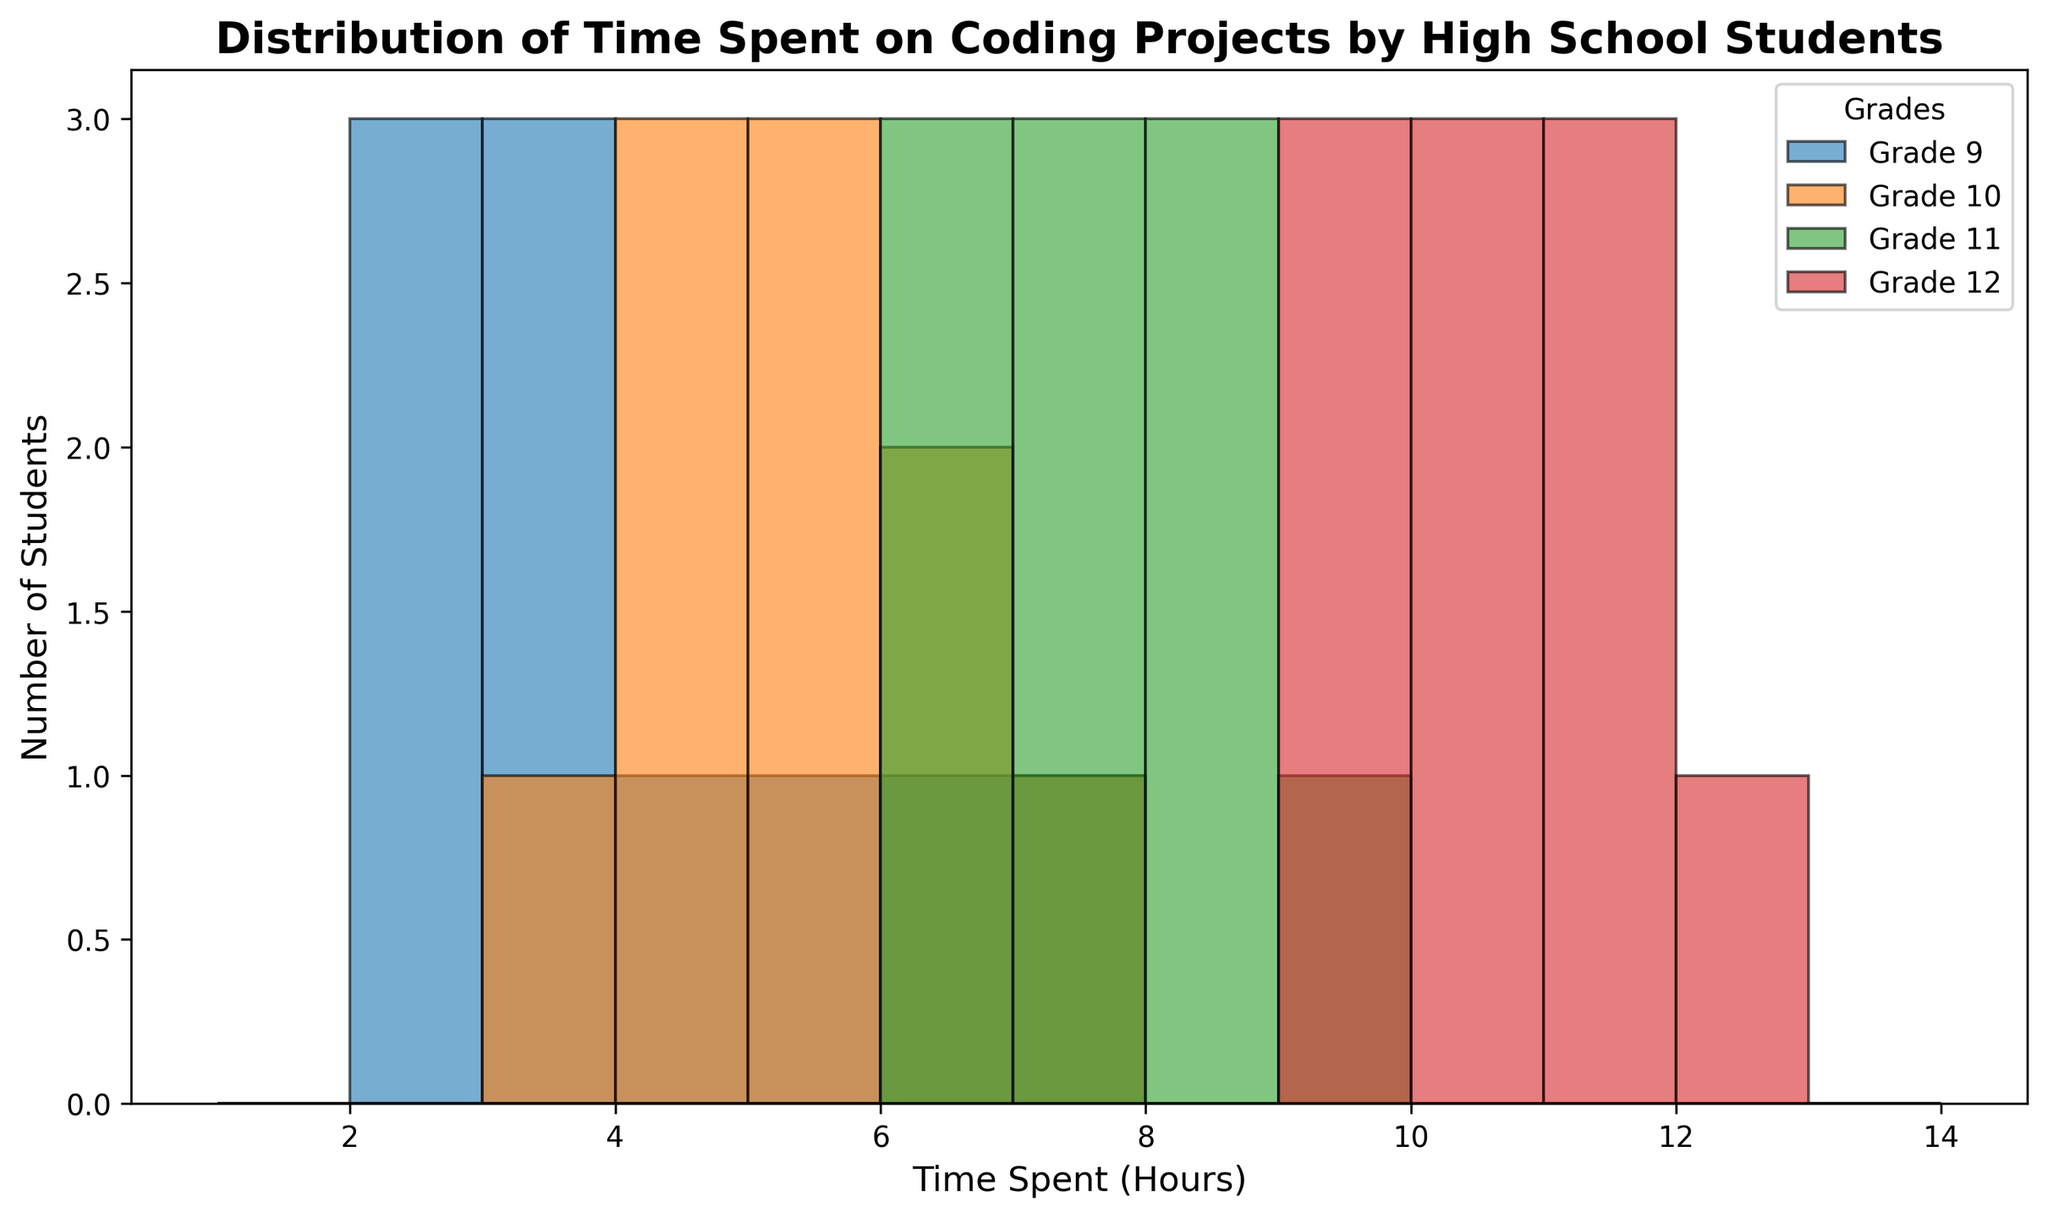What's the range of hours that 9th graders spent on coding projects? The histogram shows the range of hours spent by 9th graders spanning from the minimum to maximum values. Observing the bars representing 9th graders, we see the range starts at 2 and ends at 7 hours.
Answer: 2 to 7 hours Which grade has the highest peak in the histogram? The highest peak is identified by the tallest bar in the histogram. By comparing the height of the bars for each grade, 11th grade has the tallest peak representing 8 hours.
Answer: 11th grade What's the approximate average time spent by 12th graders on coding projects? To get the average, sum all the hours spent by 12th graders and divide by the number of students. The values are 10, 9, 11, 10, 9, 11, 12, 9, 10, 11. Sum: 102. Number of students: 10. Therefore, 102 / 10 = 10.2 hours.
Answer: 10.2 hours Which grade spent more time on coding projects on average, 10th or 11th graders? Calculate the average for each grade. For 10th grade: (4+5+6+5+4+3+6+7+5+4) = 49, divided by 10 = 4.9 hours. For 11th grade: (8+6+7+8+9+7+6+8+7+6) = 72, divided by 10 = 7.2 hours. Comparing them: 7.2 > 4.9.
Answer: 11th grade Compare the distribution of time spent on coding by 9th graders and 12th graders. The histogram shows different shapes for each grade. For 9th graders, the distribution is wider and skewed left with most students spending around 2-5 hours. For 12th graders, the distribution is more centered around 9-12 hours.
Answer: 12th graders spend more time Which grade is more consistent in the amount of time spent based on the histogram? Consistency can be judged by the spread and clustering of the bars. 12th graders show a more consistent pattern with most students spending between 9-12 hours closely clustered together.
Answer: 12th grade What is the least amount of time spent on coding projects by students in any grade? The shortest bar across the histogram indicates the least time spent. For 9th graders, the minimum time spent is 2 hours, and no other grade shows a bar below this.
Answer: 2 hours How does the number of students who spent 5 hours compare across grades? Look for the bar labeled 5 hours for each grade. Only 9th and 10th graders have bars at 5 hours. 9th graders have fewer students than 10th graders at this hour based on the bar height.
Answer: 10th grade has more 